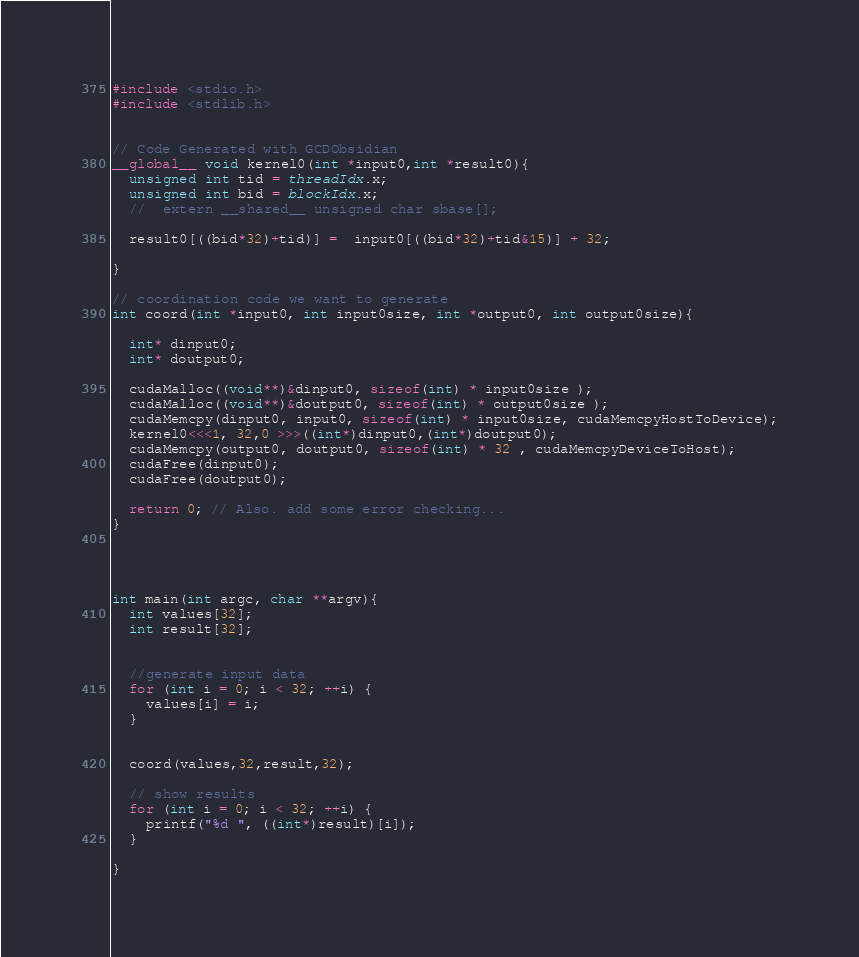<code> <loc_0><loc_0><loc_500><loc_500><_Cuda_>#include <stdio.h>
#include <stdlib.h>


// Code Generated with GCDObsidian
__global__ void kernel0(int *input0,int *result0){
  unsigned int tid = threadIdx.x;
  unsigned int bid = blockIdx.x;
  //  extern __shared__ unsigned char sbase[];

  result0[((bid*32)+tid)] =  input0[((bid*32)+tid&15)] + 32;
  
}

// coordination code we want to generate
int coord(int *input0, int input0size, int *output0, int output0size){ 
  
  int* dinput0;
  int* doutput0;

  cudaMalloc((void**)&dinput0, sizeof(int) * input0size ); 
  cudaMalloc((void**)&doutput0, sizeof(int) * output0size ); 
  cudaMemcpy(dinput0, input0, sizeof(int) * input0size, cudaMemcpyHostToDevice);
  kernel0<<<1, 32,0 >>>((int*)dinput0,(int*)doutput0);
  cudaMemcpy(output0, doutput0, sizeof(int) * 32 , cudaMemcpyDeviceToHost);
  cudaFree(dinput0);
  cudaFree(doutput0);
 
  return 0; // Also. add some error checking... 
}




int main(int argc, char **argv){
  int values[32];
  int result[32];
 

  //generate input data
  for (int i = 0; i < 32; ++i) { 
    values[i] = i; 
  }


  coord(values,32,result,32);
  
  // show results 
  for (int i = 0; i < 32; ++i) { 
    printf("%d ", ((int*)result)[i]);
  }

}

</code> 